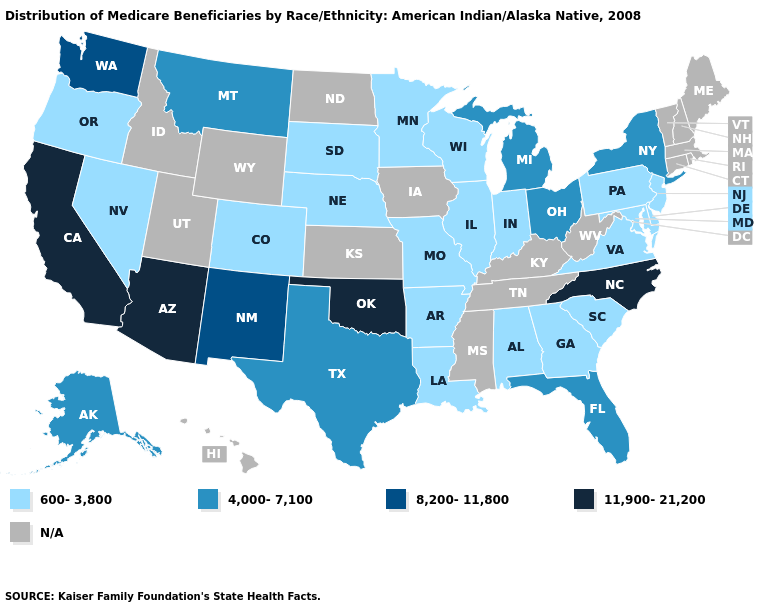What is the value of New Hampshire?
Short answer required. N/A. What is the value of Florida?
Keep it brief. 4,000-7,100. How many symbols are there in the legend?
Concise answer only. 5. Name the states that have a value in the range 4,000-7,100?
Be succinct. Alaska, Florida, Michigan, Montana, New York, Ohio, Texas. What is the value of Massachusetts?
Be succinct. N/A. Name the states that have a value in the range 4,000-7,100?
Concise answer only. Alaska, Florida, Michigan, Montana, New York, Ohio, Texas. Name the states that have a value in the range 600-3,800?
Answer briefly. Alabama, Arkansas, Colorado, Delaware, Georgia, Illinois, Indiana, Louisiana, Maryland, Minnesota, Missouri, Nebraska, Nevada, New Jersey, Oregon, Pennsylvania, South Carolina, South Dakota, Virginia, Wisconsin. What is the highest value in states that border Washington?
Keep it brief. 600-3,800. Name the states that have a value in the range 600-3,800?
Give a very brief answer. Alabama, Arkansas, Colorado, Delaware, Georgia, Illinois, Indiana, Louisiana, Maryland, Minnesota, Missouri, Nebraska, Nevada, New Jersey, Oregon, Pennsylvania, South Carolina, South Dakota, Virginia, Wisconsin. Name the states that have a value in the range N/A?
Write a very short answer. Connecticut, Hawaii, Idaho, Iowa, Kansas, Kentucky, Maine, Massachusetts, Mississippi, New Hampshire, North Dakota, Rhode Island, Tennessee, Utah, Vermont, West Virginia, Wyoming. How many symbols are there in the legend?
Quick response, please. 5. What is the highest value in the USA?
Answer briefly. 11,900-21,200. Name the states that have a value in the range 4,000-7,100?
Keep it brief. Alaska, Florida, Michigan, Montana, New York, Ohio, Texas. Among the states that border Texas , does New Mexico have the highest value?
Quick response, please. No. 